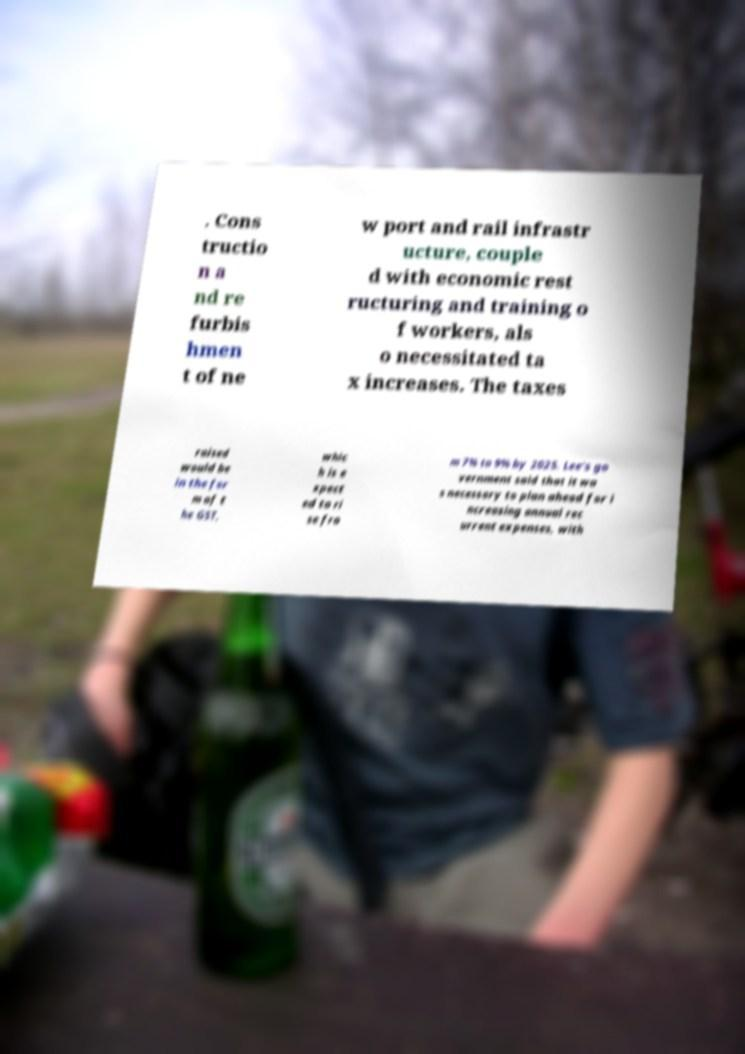Please read and relay the text visible in this image. What does it say? . Cons tructio n a nd re furbis hmen t of ne w port and rail infrastr ucture, couple d with economic rest ructuring and training o f workers, als o necessitated ta x increases. The taxes raised would be in the for m of t he GST, whic h is e xpect ed to ri se fro m 7% to 9% by 2025. Lee's go vernment said that it wa s necessary to plan ahead for i ncreasing annual rec urrent expenses, with 